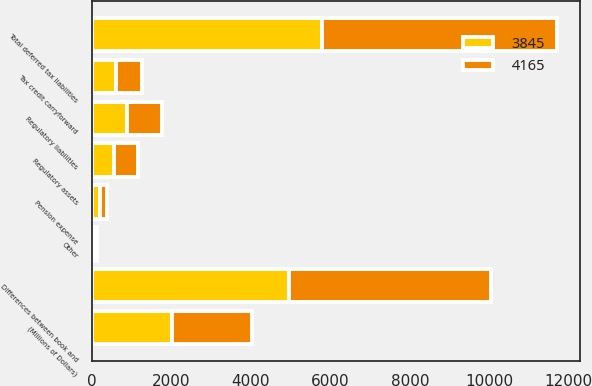Convert chart to OTSL. <chart><loc_0><loc_0><loc_500><loc_500><stacked_bar_chart><ecel><fcel>(Millions of Dollars)<fcel>Differences between book and<fcel>Regulatory assets<fcel>Pension expense<fcel>Other<fcel>Total deferred tax liabilities<fcel>Regulatory liabilities<fcel>Tax credit carryforward<nl><fcel>4165<fcel>2018<fcel>5082<fcel>599<fcel>178<fcel>64<fcel>5923<fcel>879<fcel>642<nl><fcel>3845<fcel>2017<fcel>4960<fcel>565<fcel>199<fcel>57<fcel>5781<fcel>886<fcel>607<nl></chart> 